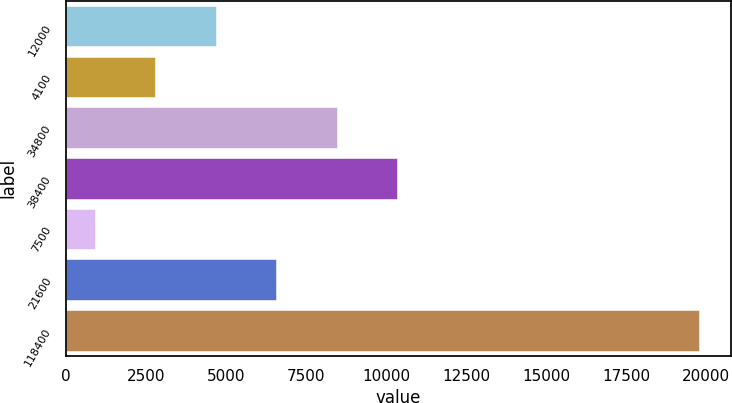<chart> <loc_0><loc_0><loc_500><loc_500><bar_chart><fcel>12000<fcel>4100<fcel>34800<fcel>38400<fcel>7500<fcel>21600<fcel>118400<nl><fcel>4680<fcel>2790<fcel>8460<fcel>10350<fcel>900<fcel>6570<fcel>19800<nl></chart> 